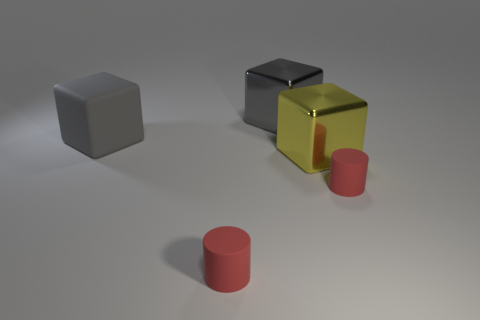What number of other big things are the same color as the large rubber thing?
Keep it short and to the point. 1. There is a rubber block; is it the same color as the cylinder that is on the right side of the yellow metallic block?
Offer a terse response. No. What number of objects are small red matte things or tiny red objects on the left side of the gray metal cube?
Your answer should be compact. 2. How big is the red thing that is on the left side of the large object in front of the big rubber thing?
Keep it short and to the point. Small. Are there the same number of red matte cylinders behind the matte block and red matte cylinders that are behind the yellow block?
Ensure brevity in your answer.  Yes. Is there a red matte cylinder behind the small red cylinder that is on the right side of the big yellow shiny thing?
Your response must be concise. No. What is the shape of the gray object that is made of the same material as the big yellow block?
Your answer should be very brief. Cube. Is there anything else of the same color as the rubber block?
Provide a short and direct response. Yes. What is the material of the red thing behind the small red matte object that is to the left of the yellow block?
Offer a very short reply. Rubber. Are there any small red rubber things that have the same shape as the big yellow thing?
Ensure brevity in your answer.  No. 